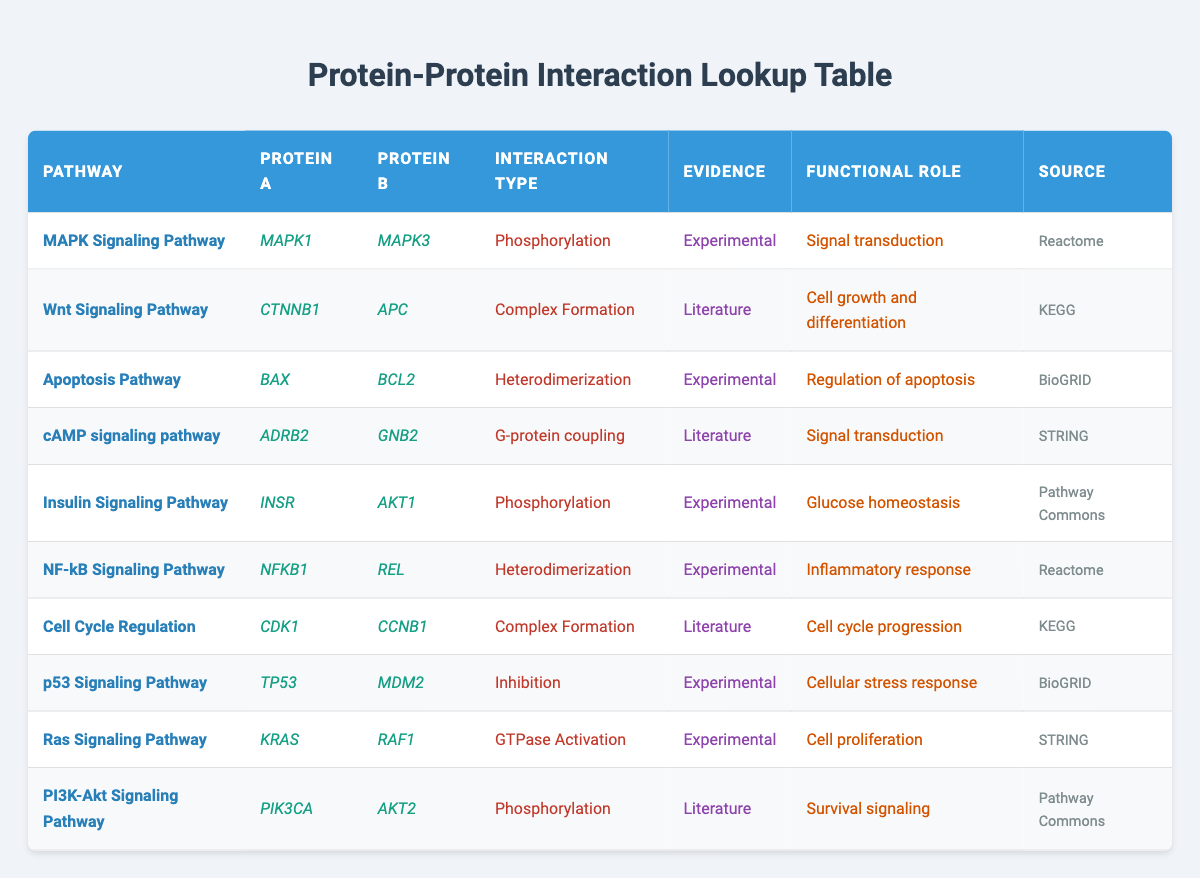What is the type of interaction between MAPK1 and MAPK3? The table lists the interaction type between MAPK1 and MAPK3 in the MAPK Signaling Pathway, which is specified as Phosphorylation.
Answer: Phosphorylation Which pathway involves proteins BAX and BCL2? Looking at the table, BAX and BCL2 are listed under the Apoptosis Pathway.
Answer: Apoptosis Pathway How many times is "Experimental" listed as evidence in the table? By counting the occurrences of "Experimental" in the Evidence column, we find it appears 5 times in the table.
Answer: 5 Is there a protein-protein interaction for INSR in Literature? Checking the table, the interaction for INSR is listed with Experimental evidence, not Literature, thus the answer is no.
Answer: No Which proteins are involved in the Wnt Signaling Pathway? The Wnt Signaling Pathway in the table includes CTNNB1 and APC as the two interacting proteins.
Answer: CTNNB1 and APC What is the functional role of the proteins in the NF-kB Signaling Pathway? The table indicates that the functional role of the proteins NFKB1 and REL in the NF-kB Signaling Pathway is related to the inflammatory response.
Answer: Inflammatory response How many interactions involved phosphorylation, and which pathways do they represent? To find this, we check the table for "Phosphorylation" under Interaction Type: it appears for MAPK1 & MAPK3 (MAPK Signaling Pathway), INSR & AKT1 (Insulin Signaling Pathway), and PIK3CA & AKT2 (PI3K-Akt Signaling Pathway), totaling three interactions.
Answer: 3 interactions: MAPK Signaling Pathway, Insulin Signaling Pathway, PI3K-Akt Signaling Pathway Which protein pairs in the table have a role in signal transduction? The table indicates that the protein pairs involved in signal transduction are MAPK1 & MAPK3 (MAPK Signaling Pathway) and ADRB2 & GNB2 (cAMP signaling pathway), thus two pairs are involved.
Answer: 2 pairs: MAPK1 & MAPK3, ADRB2 & GNB2 What is the highest number of interaction types listed for any single pathway? In the table, each pathway is only represented once, so the highest number of different interaction types is one per pathway. Since there is no pathway with multiple interaction types, the answer is simply one.
Answer: 1 